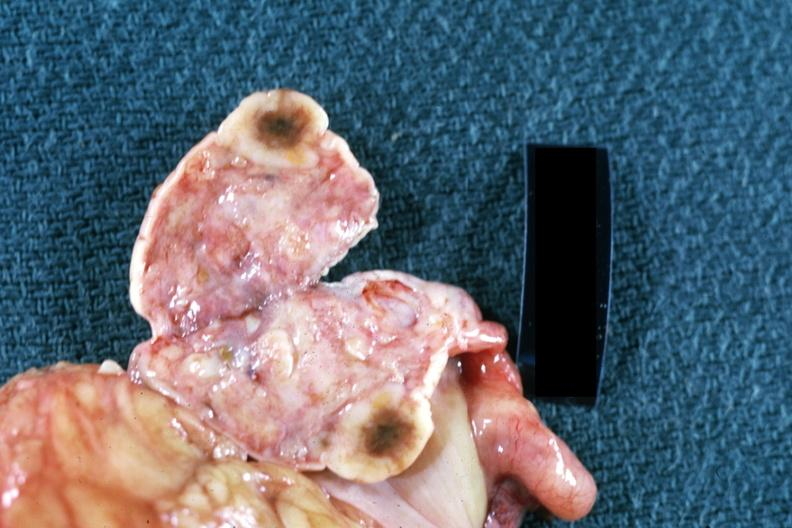what does this image show?
Answer the question using a single word or phrase. Cut surface of ovary close up breast primary 